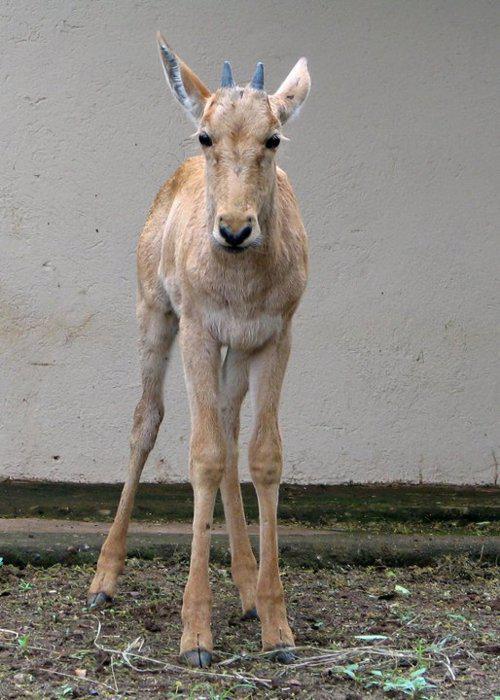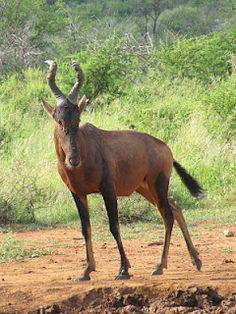The first image is the image on the left, the second image is the image on the right. Examine the images to the left and right. Is the description "There are exactly two animals standing." accurate? Answer yes or no. Yes. The first image is the image on the left, the second image is the image on the right. Examine the images to the left and right. Is the description "Only two antelopes are visible in the left image." accurate? Answer yes or no. No. 